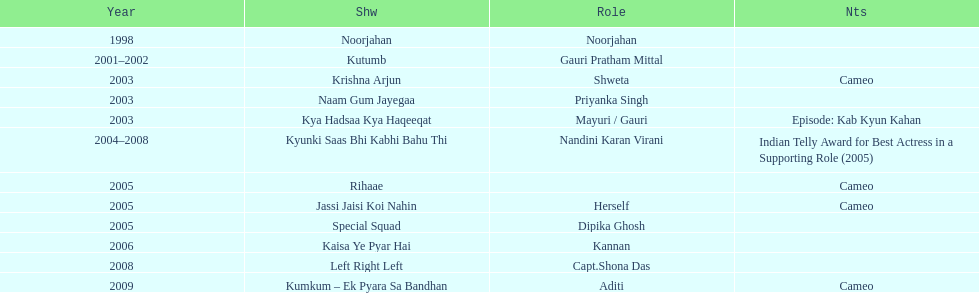Which was the only television show gauri starred in, in which she played herself? Jassi Jaisi Koi Nahin. I'm looking to parse the entire table for insights. Could you assist me with that? {'header': ['Year', 'Shw', 'Role', 'Nts'], 'rows': [['1998', 'Noorjahan', 'Noorjahan', ''], ['2001–2002', 'Kutumb', 'Gauri Pratham Mittal', ''], ['2003', 'Krishna Arjun', 'Shweta', 'Cameo'], ['2003', 'Naam Gum Jayegaa', 'Priyanka Singh', ''], ['2003', 'Kya Hadsaa Kya Haqeeqat', 'Mayuri / Gauri', 'Episode: Kab Kyun Kahan'], ['2004–2008', 'Kyunki Saas Bhi Kabhi Bahu Thi', 'Nandini Karan Virani', 'Indian Telly Award for Best Actress in a Supporting Role (2005)'], ['2005', 'Rihaae', '', 'Cameo'], ['2005', 'Jassi Jaisi Koi Nahin', 'Herself', 'Cameo'], ['2005', 'Special Squad', 'Dipika Ghosh', ''], ['2006', 'Kaisa Ye Pyar Hai', 'Kannan', ''], ['2008', 'Left Right Left', 'Capt.Shona Das', ''], ['2009', 'Kumkum – Ek Pyara Sa Bandhan', 'Aditi', 'Cameo']]} 